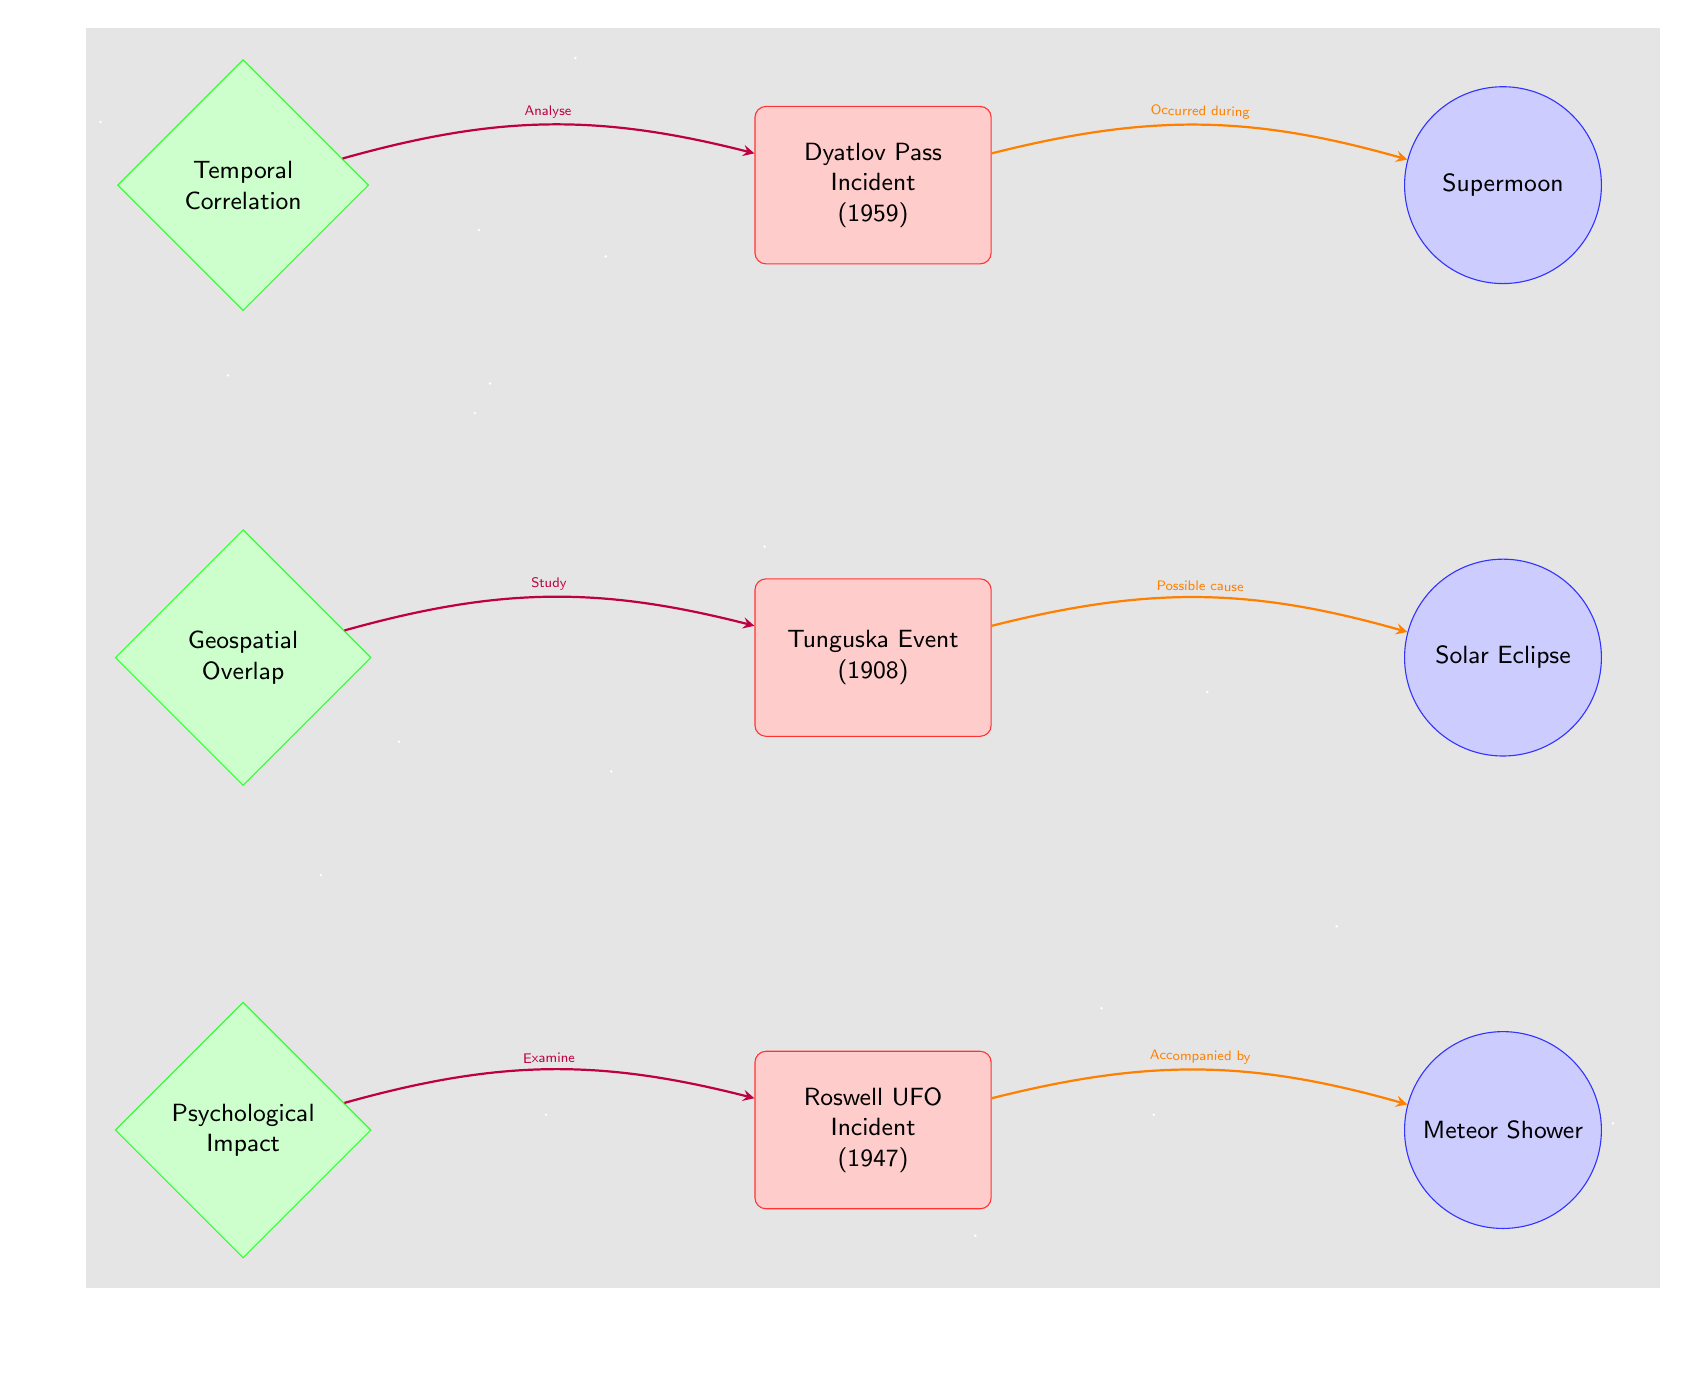What is the first mystery case in the diagram? The topmost node labeled as a mystery case is "Dyatlov Pass Incident (1959)," which is the first listed case in the diagram.
Answer: Dyatlov Pass Incident (1959) How many astronomical events are represented in the diagram? There are three nodes labeled as astronomical events: Supermoon, Solar Eclipse, and Meteor Shower. Counting them gives a total of three.
Answer: 3 Which pattern analysis is associated with the Roswell UFO Incident? The connection labeled "Examine" routes from the "Psychological Impact" node to the "Roswell UFO Incident (1947)" node, indicating this analysis is involved with the case.
Answer: Psychological Impact Which mystery case occurred during the Supermoon? The arrow labeled "Occurred during" connects the "Dyatlov Pass Incident (1959)" node to the "Supermoon" node, indicating that this case is associated with the Supermoon.
Answer: Dyatlov Pass Incident (1959) Is there a connection labeled as a possible cause? Yes, the diagram shows an arrow labeled "Possible cause" connecting the "Tunguska Event (1908)" mystery case to the "Solar Eclipse" astronomical event node. This indicates that the eclipse is suggested as a possible cause for the event.
Answer: Yes What type of connection connects the Geospatial Overlap pattern to the Tunguska Event? The connection from "Geospatial Overlap" to "Tunguska Event (1908)" is labeled "Study," which indicates that a study is being conducted on this relationship.
Answer: Study What color represents the pattern analysis nodes? The pattern analysis nodes are represented in a green hue, specifically a green background with a darker green outline, as per the diagram's color scheme.
Answer: Green Which astronomical event is accompanied by the Roswell UFO Incident? The arrow from the "Meteor Shower" node to the "Roswell UFO Incident (1947)" node indicates that the incident is associated with the Meteor Shower.
Answer: Meteor Shower 